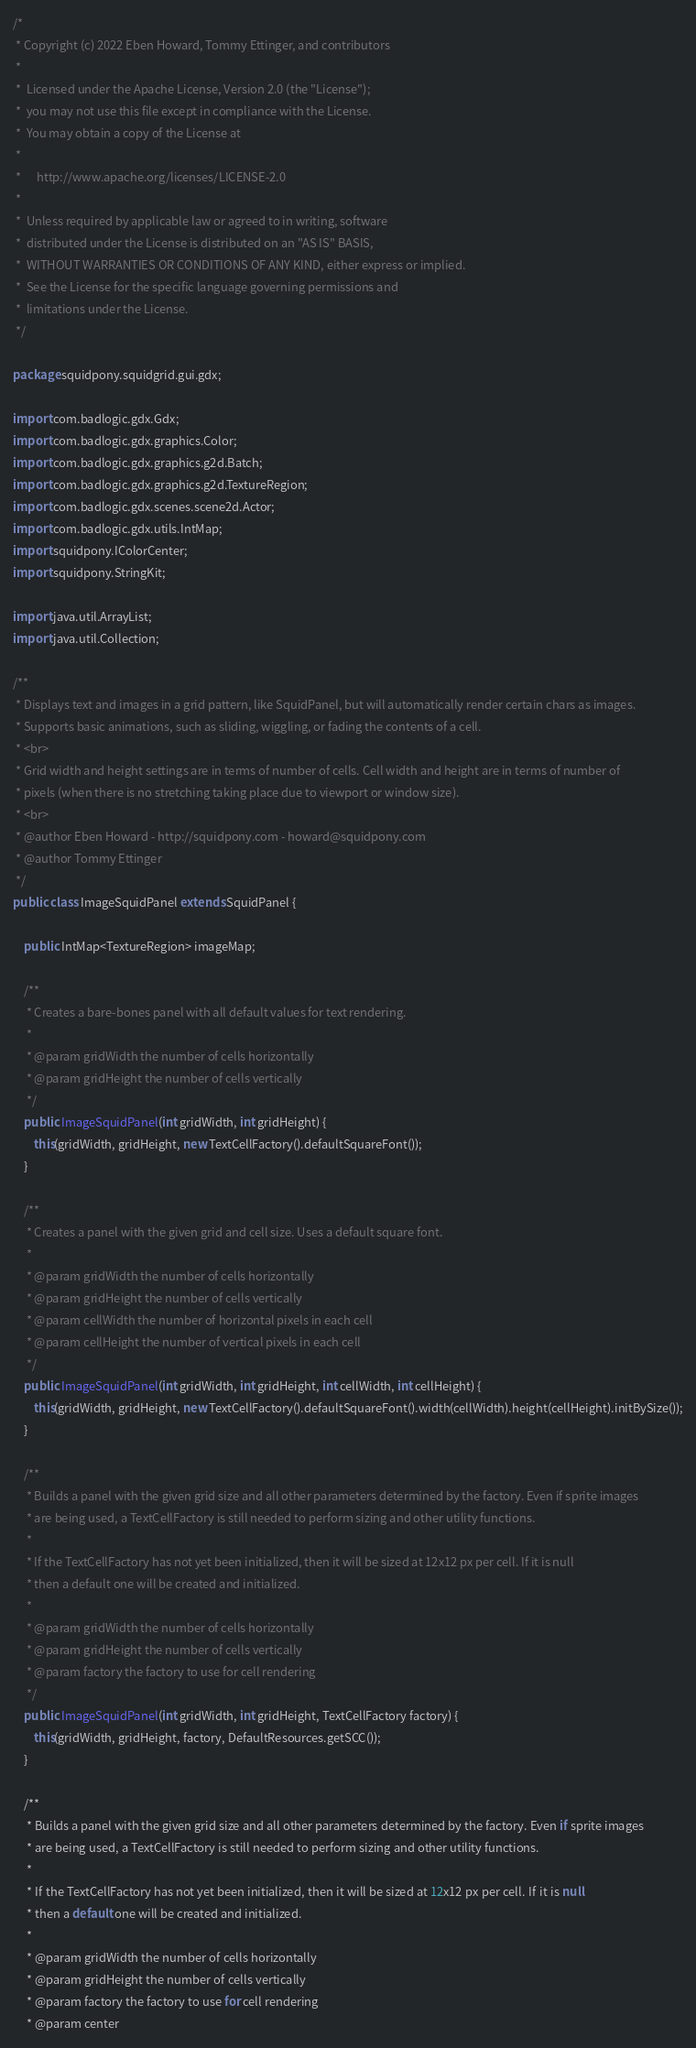<code> <loc_0><loc_0><loc_500><loc_500><_Java_>/*
 * Copyright (c) 2022 Eben Howard, Tommy Ettinger, and contributors
 *
 *  Licensed under the Apache License, Version 2.0 (the "License");
 *  you may not use this file except in compliance with the License.
 *  You may obtain a copy of the License at
 *
 *      http://www.apache.org/licenses/LICENSE-2.0
 *
 *  Unless required by applicable law or agreed to in writing, software
 *  distributed under the License is distributed on an "AS IS" BASIS,
 *  WITHOUT WARRANTIES OR CONDITIONS OF ANY KIND, either express or implied.
 *  See the License for the specific language governing permissions and
 *  limitations under the License.
 */

package squidpony.squidgrid.gui.gdx;

import com.badlogic.gdx.Gdx;
import com.badlogic.gdx.graphics.Color;
import com.badlogic.gdx.graphics.g2d.Batch;
import com.badlogic.gdx.graphics.g2d.TextureRegion;
import com.badlogic.gdx.scenes.scene2d.Actor;
import com.badlogic.gdx.utils.IntMap;
import squidpony.IColorCenter;
import squidpony.StringKit;

import java.util.ArrayList;
import java.util.Collection;

/**
 * Displays text and images in a grid pattern, like SquidPanel, but will automatically render certain chars as images.
 * Supports basic animations, such as sliding, wiggling, or fading the contents of a cell.
 * <br>
 * Grid width and height settings are in terms of number of cells. Cell width and height are in terms of number of
 * pixels (when there is no stretching taking place due to viewport or window size).
 * <br>
 * @author Eben Howard - http://squidpony.com - howard@squidpony.com
 * @author Tommy Ettinger
 */
public class ImageSquidPanel extends SquidPanel {

    public IntMap<TextureRegion> imageMap;

    /**
     * Creates a bare-bones panel with all default values for text rendering.
     *
     * @param gridWidth the number of cells horizontally
     * @param gridHeight the number of cells vertically
     */
    public ImageSquidPanel(int gridWidth, int gridHeight) {
        this(gridWidth, gridHeight, new TextCellFactory().defaultSquareFont());
    }

    /**
     * Creates a panel with the given grid and cell size. Uses a default square font.
     *
     * @param gridWidth the number of cells horizontally
     * @param gridHeight the number of cells vertically
     * @param cellWidth the number of horizontal pixels in each cell
     * @param cellHeight the number of vertical pixels in each cell
     */
    public ImageSquidPanel(int gridWidth, int gridHeight, int cellWidth, int cellHeight) {
        this(gridWidth, gridHeight, new TextCellFactory().defaultSquareFont().width(cellWidth).height(cellHeight).initBySize());
    }

    /**
     * Builds a panel with the given grid size and all other parameters determined by the factory. Even if sprite images
     * are being used, a TextCellFactory is still needed to perform sizing and other utility functions.
     *
     * If the TextCellFactory has not yet been initialized, then it will be sized at 12x12 px per cell. If it is null
     * then a default one will be created and initialized.
     *
     * @param gridWidth the number of cells horizontally
     * @param gridHeight the number of cells vertically
     * @param factory the factory to use for cell rendering
     */
    public ImageSquidPanel(int gridWidth, int gridHeight, TextCellFactory factory) {
        this(gridWidth, gridHeight, factory, DefaultResources.getSCC());
    }

    /**
     * Builds a panel with the given grid size and all other parameters determined by the factory. Even if sprite images
     * are being used, a TextCellFactory is still needed to perform sizing and other utility functions.
     *
     * If the TextCellFactory has not yet been initialized, then it will be sized at 12x12 px per cell. If it is null
     * then a default one will be created and initialized.
     *
     * @param gridWidth the number of cells horizontally
     * @param gridHeight the number of cells vertically
     * @param factory the factory to use for cell rendering
     * @param center</code> 